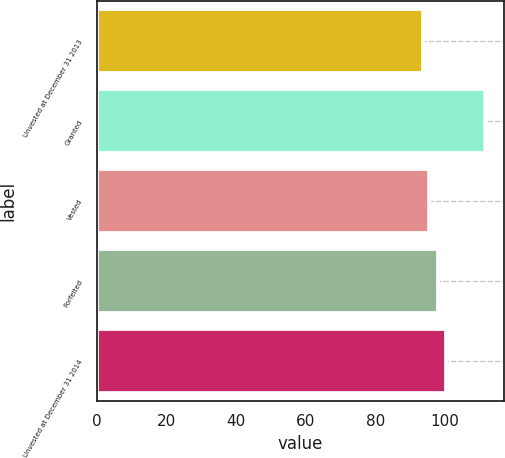Convert chart to OTSL. <chart><loc_0><loc_0><loc_500><loc_500><bar_chart><fcel>Unvested at December 31 2013<fcel>Granted<fcel>Vested<fcel>Forfeited<fcel>Unvested at December 31 2014<nl><fcel>93.71<fcel>111.45<fcel>95.48<fcel>98.02<fcel>100.45<nl></chart> 